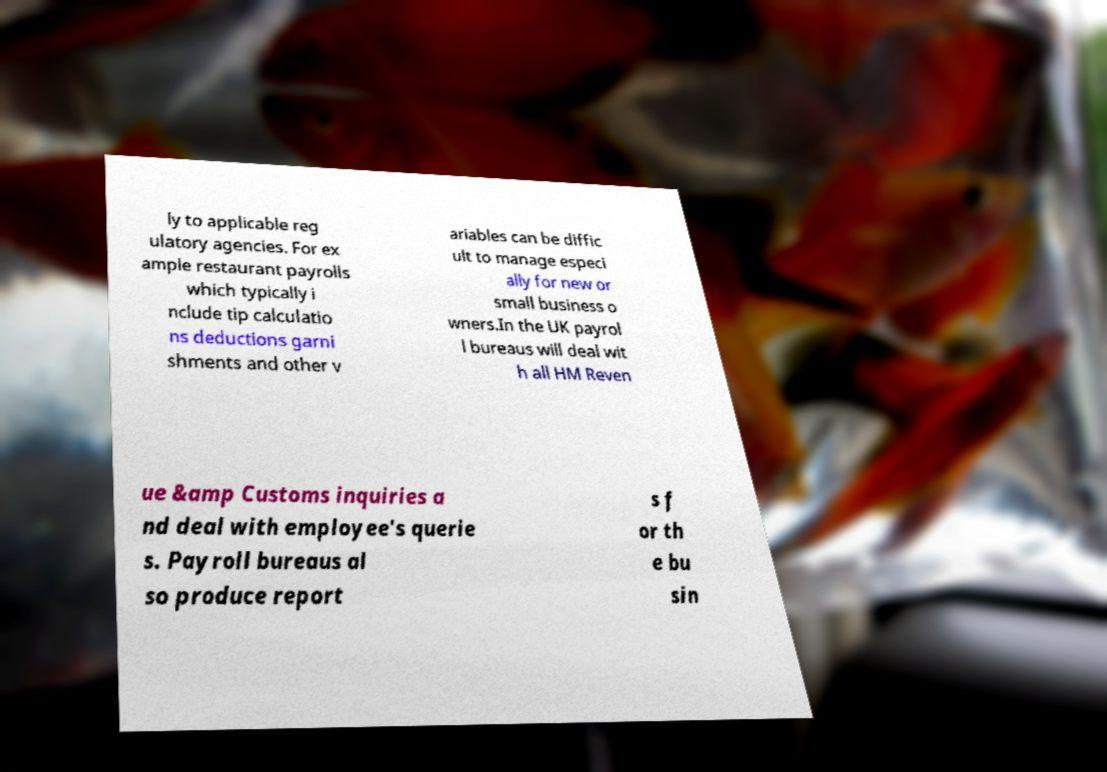I need the written content from this picture converted into text. Can you do that? ly to applicable reg ulatory agencies. For ex ample restaurant payrolls which typically i nclude tip calculatio ns deductions garni shments and other v ariables can be diffic ult to manage especi ally for new or small business o wners.In the UK payrol l bureaus will deal wit h all HM Reven ue &amp Customs inquiries a nd deal with employee's querie s. Payroll bureaus al so produce report s f or th e bu sin 